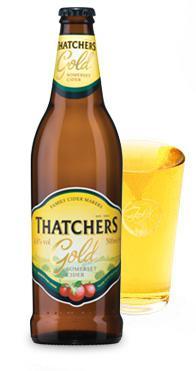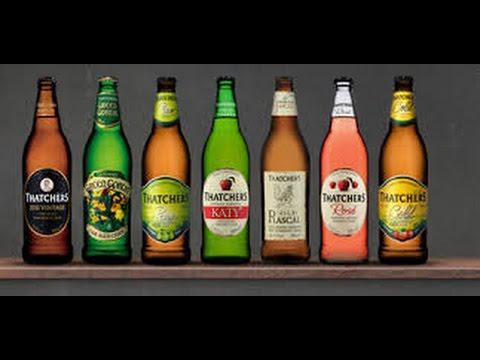The first image is the image on the left, the second image is the image on the right. Examine the images to the left and right. Is the description "Each image contains the same number of capped bottles, all with different labels." accurate? Answer yes or no. No. The first image is the image on the left, the second image is the image on the right. Evaluate the accuracy of this statement regarding the images: "The right and left images contain the same number of bottles.". Is it true? Answer yes or no. No. 